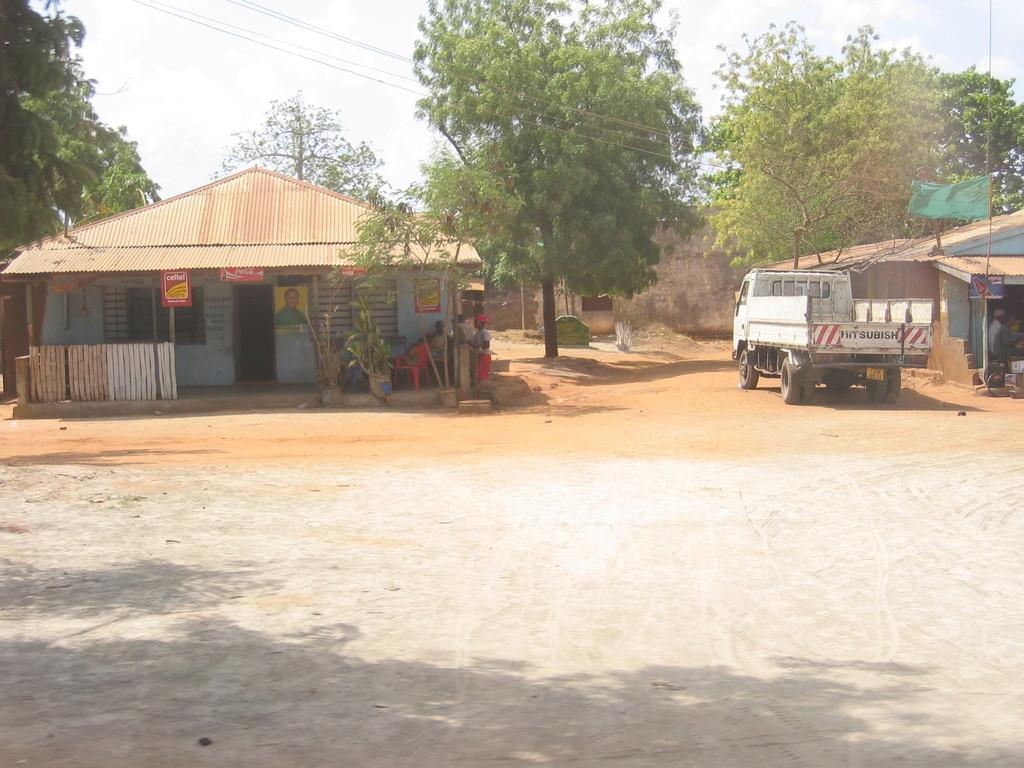What is on the road in the image? There is a vehicle on the road in the image. What can be seen in the background of the image? There are buildings in the image. What is attached to the wall in the image? Posters are attached to the wall in the image. Can you describe the people in the image? There is a group of people in the image. What type of furniture is present in the image? Chairs are present in the image. What type of vegetation is visible in the image? Plants and trees are visible in the image. What is visible at the top of the image? The sky is visible in the image. How does the man in the image cough while looking at his brain? There is no man, coughing, or brain present in the image. 